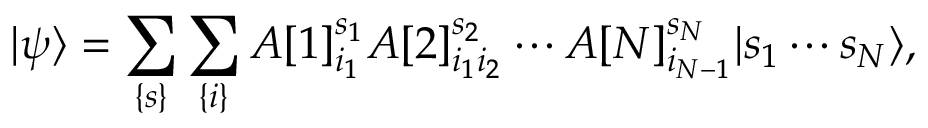<formula> <loc_0><loc_0><loc_500><loc_500>| \psi \rangle = \sum _ { \{ s \} } \sum _ { \{ i \} } A [ 1 ] _ { i _ { 1 } } ^ { s _ { 1 } } A [ 2 ] _ { i _ { 1 } i _ { 2 } } ^ { s _ { 2 } } \cdots A [ N ] _ { i _ { N - 1 } } ^ { s _ { N } } | s _ { 1 } \cdots s _ { N } \rangle ,</formula> 